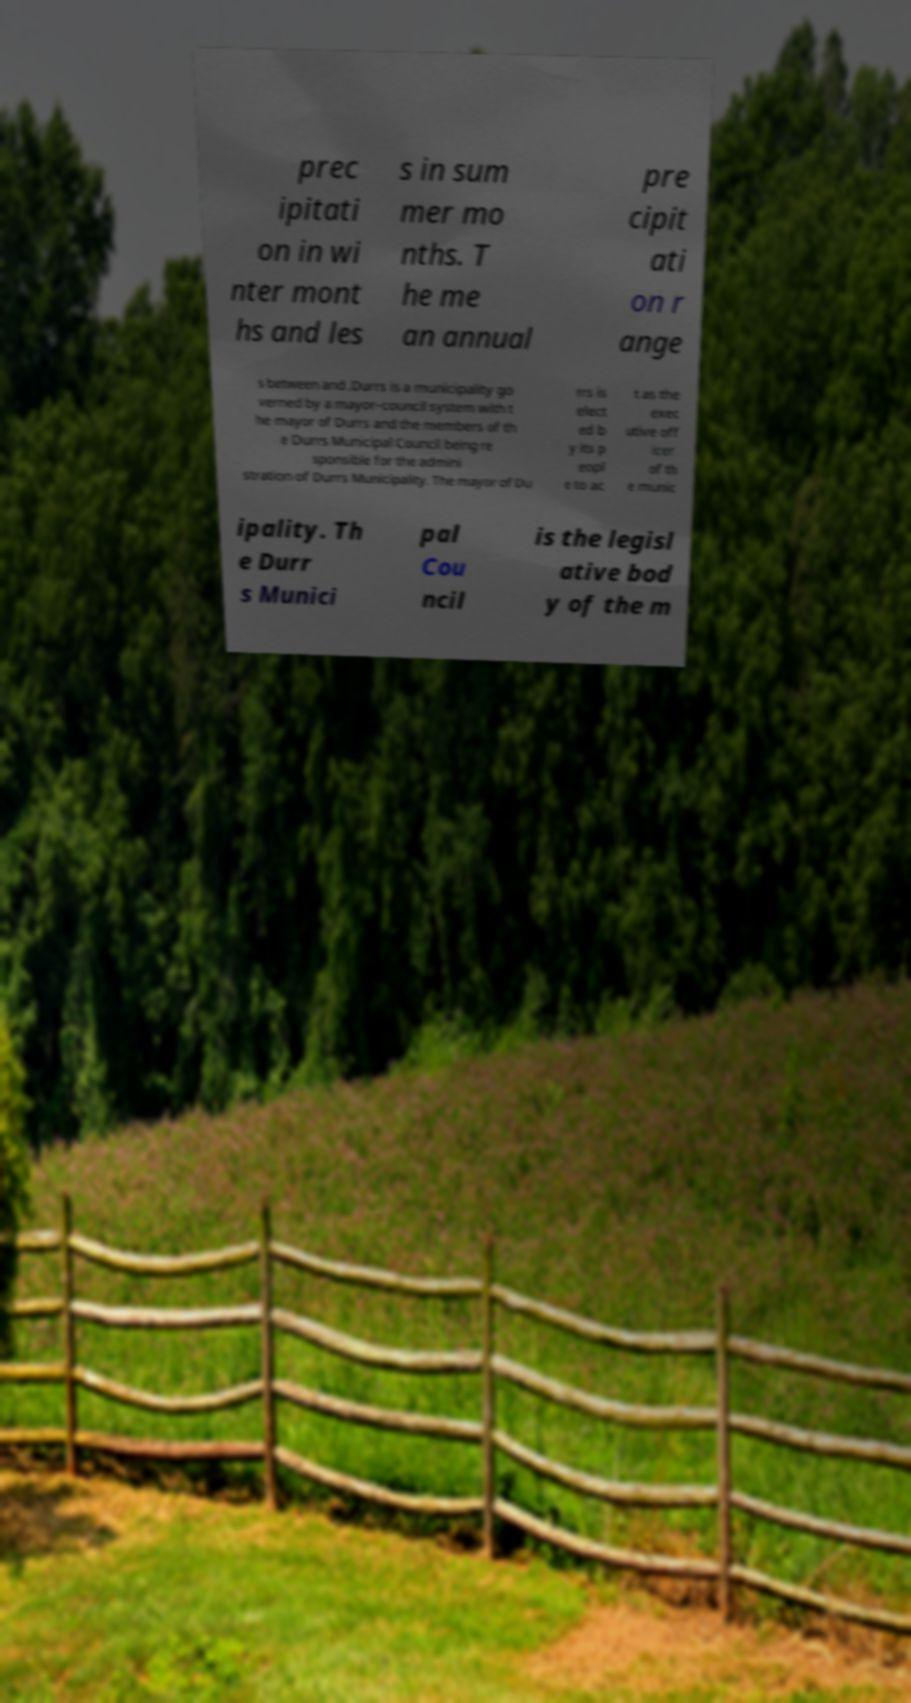Could you extract and type out the text from this image? prec ipitati on in wi nter mont hs and les s in sum mer mo nths. T he me an annual pre cipit ati on r ange s between and .Durrs is a municipality go verned by a mayor–council system with t he mayor of Durrs and the members of th e Durrs Municipal Council being re sponsible for the admini stration of Durrs Municipality. The mayor of Du rrs is elect ed b y its p eopl e to ac t as the exec utive off icer of th e munic ipality. Th e Durr s Munici pal Cou ncil is the legisl ative bod y of the m 